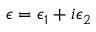Convert formula to latex. <formula><loc_0><loc_0><loc_500><loc_500>\epsilon = \epsilon _ { 1 } + i \epsilon _ { 2 }</formula> 